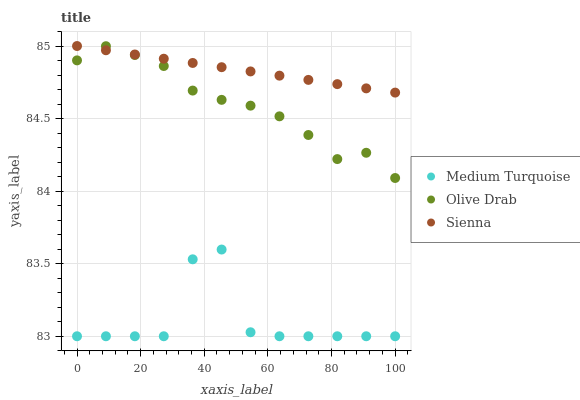Does Medium Turquoise have the minimum area under the curve?
Answer yes or no. Yes. Does Sienna have the maximum area under the curve?
Answer yes or no. Yes. Does Olive Drab have the minimum area under the curve?
Answer yes or no. No. Does Olive Drab have the maximum area under the curve?
Answer yes or no. No. Is Sienna the smoothest?
Answer yes or no. Yes. Is Medium Turquoise the roughest?
Answer yes or no. Yes. Is Olive Drab the smoothest?
Answer yes or no. No. Is Olive Drab the roughest?
Answer yes or no. No. Does Medium Turquoise have the lowest value?
Answer yes or no. Yes. Does Olive Drab have the lowest value?
Answer yes or no. No. Does Sienna have the highest value?
Answer yes or no. Yes. Does Olive Drab have the highest value?
Answer yes or no. No. Is Medium Turquoise less than Sienna?
Answer yes or no. Yes. Is Sienna greater than Medium Turquoise?
Answer yes or no. Yes. Does Olive Drab intersect Sienna?
Answer yes or no. Yes. Is Olive Drab less than Sienna?
Answer yes or no. No. Is Olive Drab greater than Sienna?
Answer yes or no. No. Does Medium Turquoise intersect Sienna?
Answer yes or no. No. 